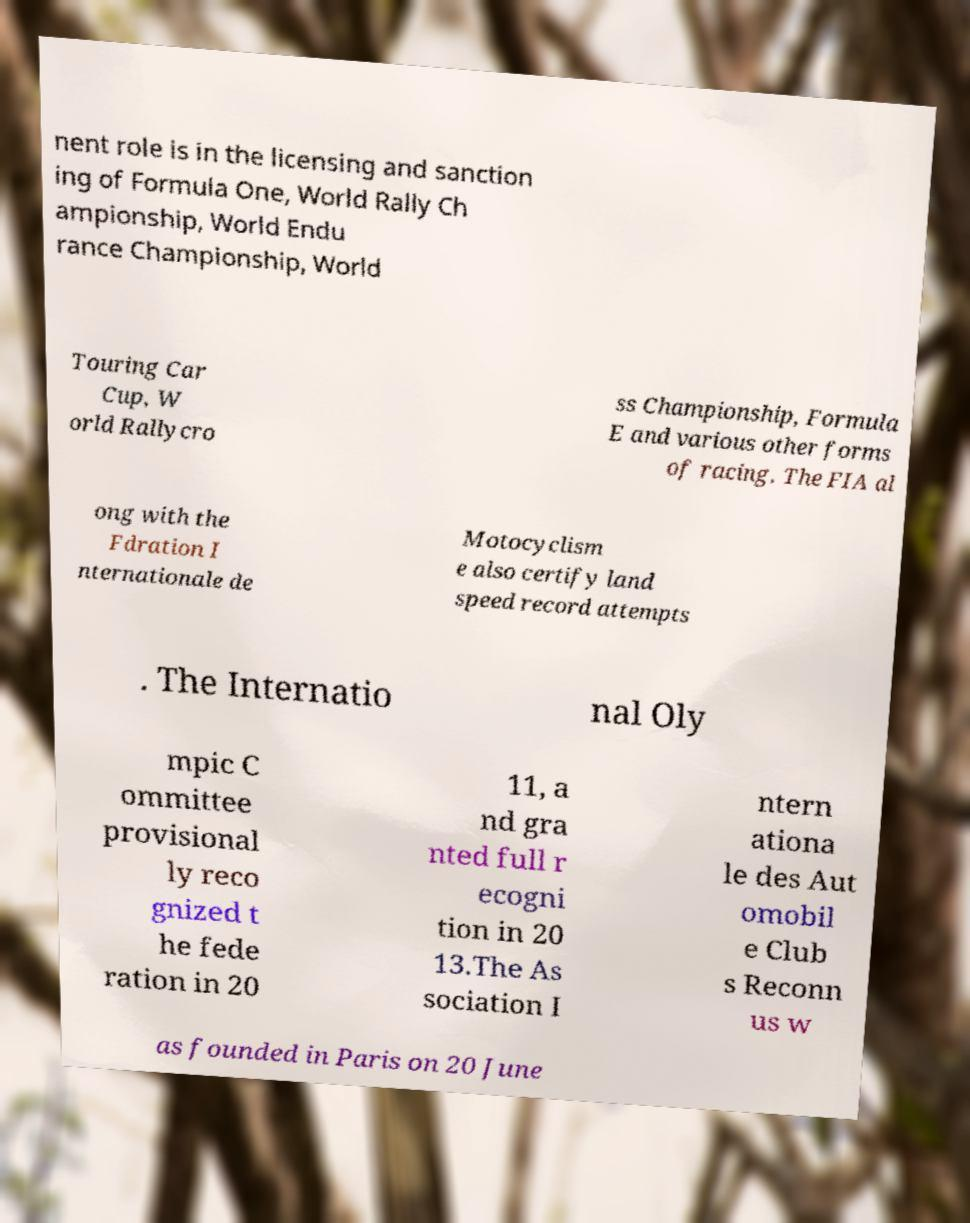There's text embedded in this image that I need extracted. Can you transcribe it verbatim? nent role is in the licensing and sanction ing of Formula One, World Rally Ch ampionship, World Endu rance Championship, World Touring Car Cup, W orld Rallycro ss Championship, Formula E and various other forms of racing. The FIA al ong with the Fdration I nternationale de Motocyclism e also certify land speed record attempts . The Internatio nal Oly mpic C ommittee provisional ly reco gnized t he fede ration in 20 11, a nd gra nted full r ecogni tion in 20 13.The As sociation I ntern ationa le des Aut omobil e Club s Reconn us w as founded in Paris on 20 June 